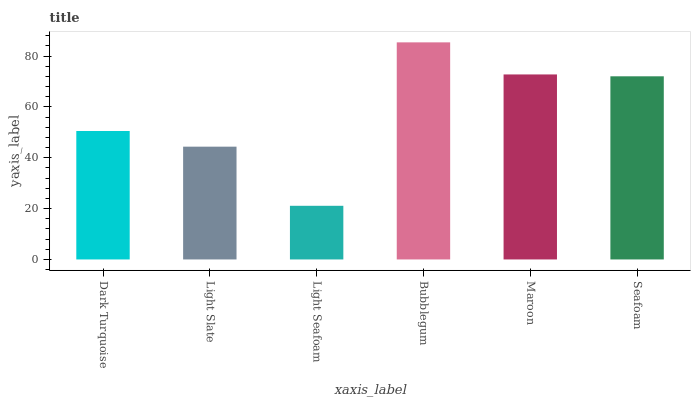Is Light Seafoam the minimum?
Answer yes or no. Yes. Is Bubblegum the maximum?
Answer yes or no. Yes. Is Light Slate the minimum?
Answer yes or no. No. Is Light Slate the maximum?
Answer yes or no. No. Is Dark Turquoise greater than Light Slate?
Answer yes or no. Yes. Is Light Slate less than Dark Turquoise?
Answer yes or no. Yes. Is Light Slate greater than Dark Turquoise?
Answer yes or no. No. Is Dark Turquoise less than Light Slate?
Answer yes or no. No. Is Seafoam the high median?
Answer yes or no. Yes. Is Dark Turquoise the low median?
Answer yes or no. Yes. Is Light Seafoam the high median?
Answer yes or no. No. Is Light Slate the low median?
Answer yes or no. No. 